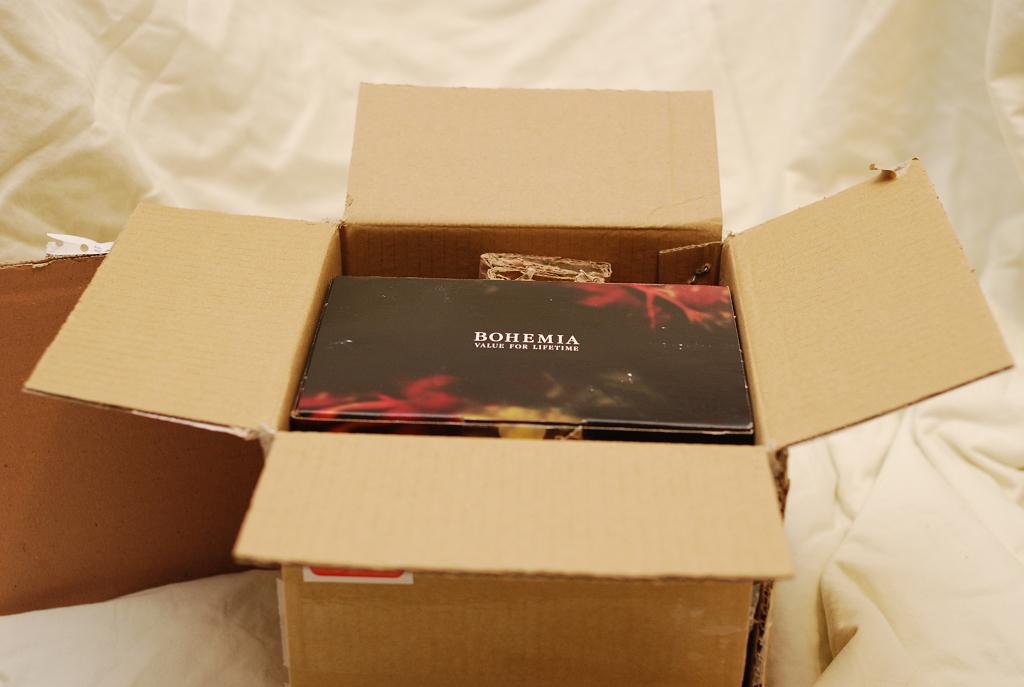What is the brand?
Provide a short and direct response. Bohemia. 